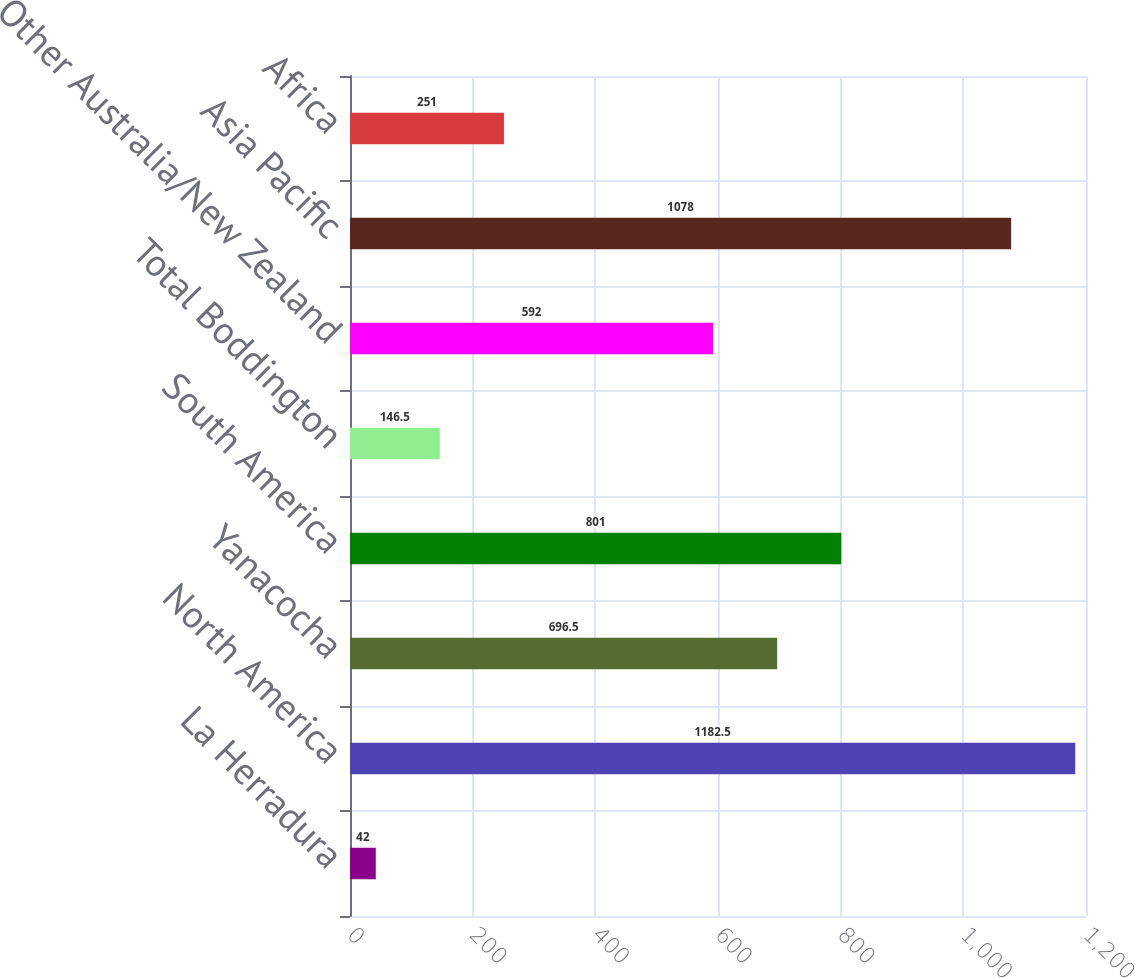Convert chart to OTSL. <chart><loc_0><loc_0><loc_500><loc_500><bar_chart><fcel>La Herradura<fcel>North America<fcel>Yanacocha<fcel>South America<fcel>Total Boddington<fcel>Other Australia/New Zealand<fcel>Asia Pacific<fcel>Africa<nl><fcel>42<fcel>1182.5<fcel>696.5<fcel>801<fcel>146.5<fcel>592<fcel>1078<fcel>251<nl></chart> 